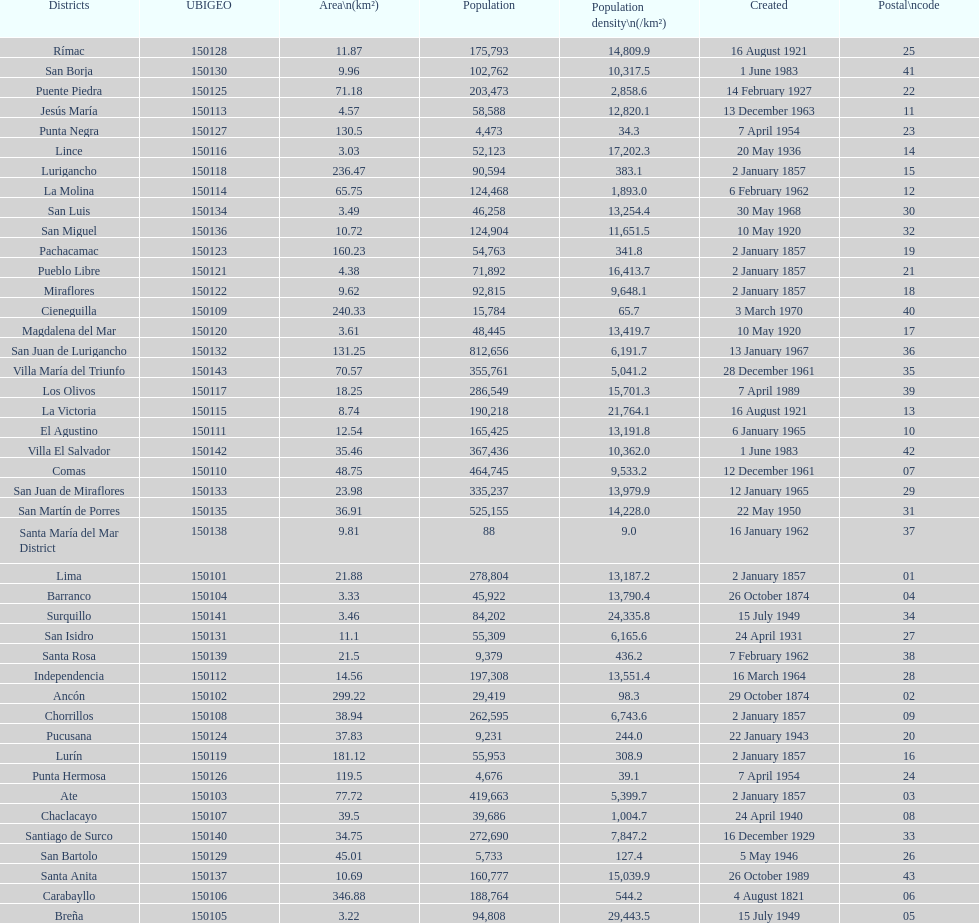How many districts have more than 100,000 people in this city? 21. 